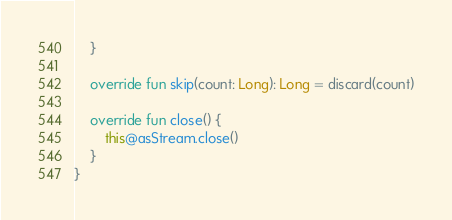Convert code to text. <code><loc_0><loc_0><loc_500><loc_500><_Kotlin_>    }

    override fun skip(count: Long): Long = discard(count)

    override fun close() {
        this@asStream.close()
    }
}

</code> 